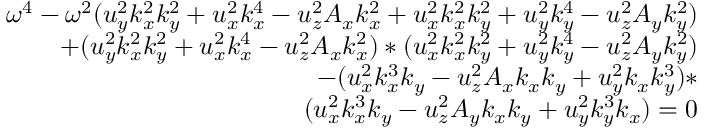Convert formula to latex. <formula><loc_0><loc_0><loc_500><loc_500>\begin{array} { r } { \omega ^ { 4 } - \omega ^ { 2 } ( u _ { y } ^ { 2 } k _ { x } ^ { 2 } k _ { y } ^ { 2 } + u _ { x } ^ { 2 } k _ { x } ^ { 4 } - u _ { z } ^ { 2 } A _ { x } k _ { x } ^ { 2 } + u _ { x } ^ { 2 } k _ { x } ^ { 2 } k _ { y } ^ { 2 } + u _ { y } ^ { 2 } k _ { y } ^ { 4 } - u _ { z } ^ { 2 } A _ { y } k _ { y } ^ { 2 } ) } \\ { + ( u _ { y } ^ { 2 } k _ { x } ^ { 2 } k _ { y } ^ { 2 } + u _ { x } ^ { 2 } k _ { x } ^ { 4 } - u _ { z } ^ { 2 } A _ { x } k _ { x } ^ { 2 } ) * ( u _ { x } ^ { 2 } k _ { x } ^ { 2 } k _ { y } ^ { 2 } + u _ { y } ^ { 2 } k _ { y } ^ { 4 } - u _ { z } ^ { 2 } A _ { y } k _ { y } ^ { 2 } ) } \\ { - ( u _ { x } ^ { 2 } k _ { x } ^ { 3 } k _ { y } - u _ { z } ^ { 2 } A _ { x } k _ { x } k _ { y } + u _ { y } ^ { 2 } k _ { x } k _ { y } ^ { 3 } ) * } \\ { ( u _ { x } ^ { 2 } k _ { x } ^ { 3 } k _ { y } - u _ { z } ^ { 2 } A _ { y } k _ { x } k _ { y } + u _ { y } ^ { 2 } k _ { y } ^ { 3 } k _ { x } ) = 0 } \end{array}</formula> 